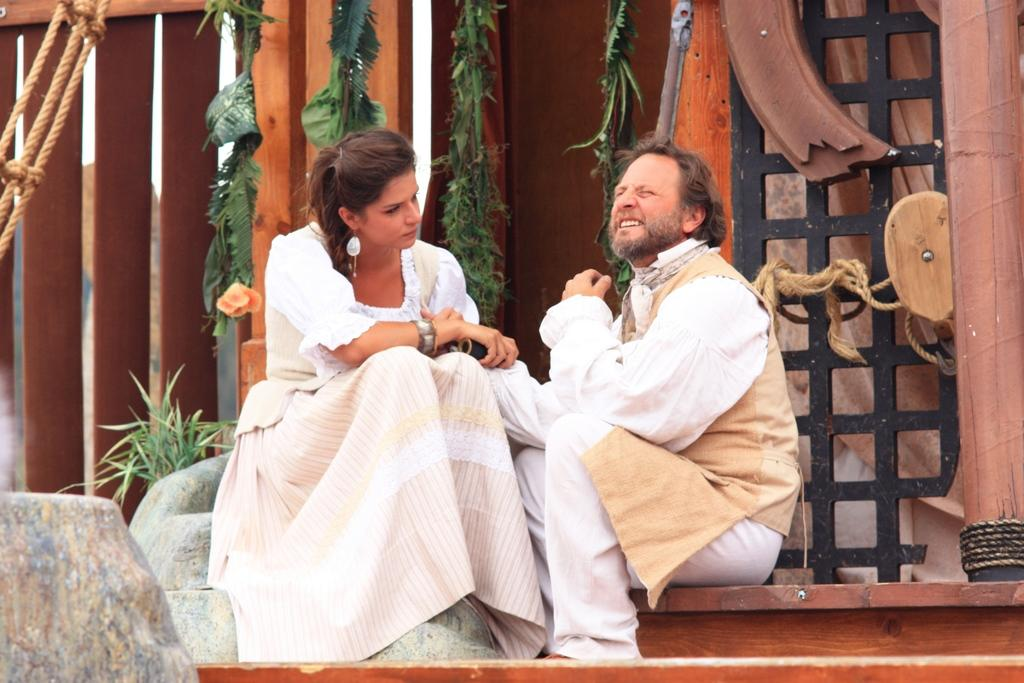How many people are sitting in the image? There are two people sitting in the image. What is one person doing with their hands? One person is holding an object. What type of vegetation can be seen in the image? There are plants in the image. What other items are present in the image? There are ropes in the image. What type of bears can be seen interacting with the people in the image? There are no bears present in the image; it only features two people and the objects they are holding or interacting with. What subject is being taught in the class depicted in the image? There is no class or educational setting depicted in the image. 